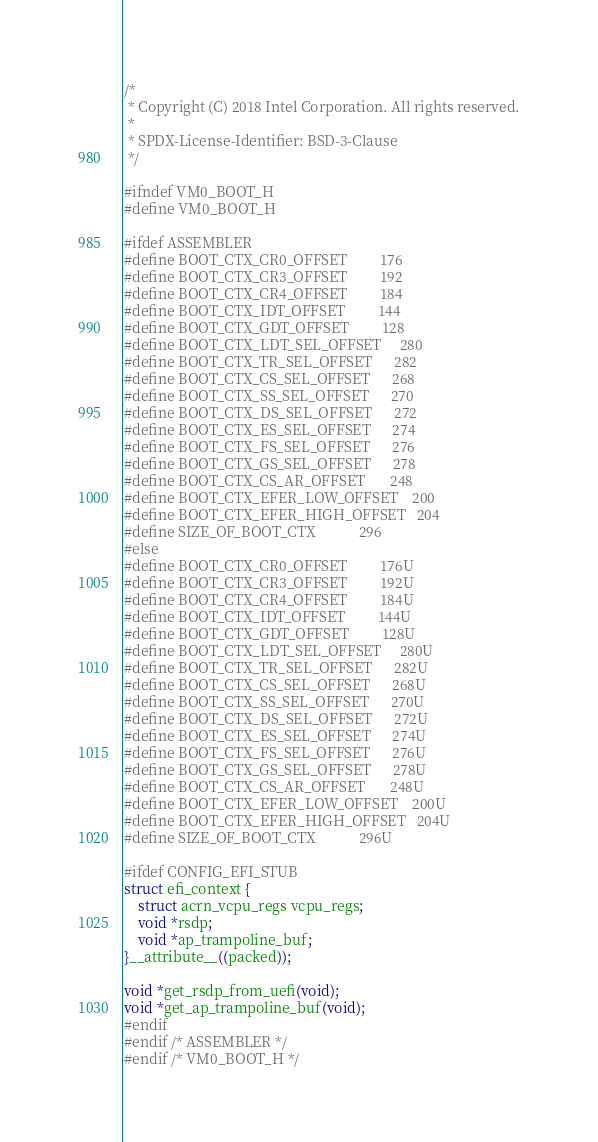Convert code to text. <code><loc_0><loc_0><loc_500><loc_500><_C_>/*
 * Copyright (C) 2018 Intel Corporation. All rights reserved.
 *
 * SPDX-License-Identifier: BSD-3-Clause
 */

#ifndef VM0_BOOT_H
#define VM0_BOOT_H

#ifdef ASSEMBLER
#define BOOT_CTX_CR0_OFFSET         176
#define BOOT_CTX_CR3_OFFSET         192
#define BOOT_CTX_CR4_OFFSET         184
#define BOOT_CTX_IDT_OFFSET         144
#define BOOT_CTX_GDT_OFFSET         128
#define BOOT_CTX_LDT_SEL_OFFSET     280
#define BOOT_CTX_TR_SEL_OFFSET      282
#define BOOT_CTX_CS_SEL_OFFSET      268
#define BOOT_CTX_SS_SEL_OFFSET      270
#define BOOT_CTX_DS_SEL_OFFSET      272
#define BOOT_CTX_ES_SEL_OFFSET      274
#define BOOT_CTX_FS_SEL_OFFSET      276
#define BOOT_CTX_GS_SEL_OFFSET      278
#define BOOT_CTX_CS_AR_OFFSET       248
#define BOOT_CTX_EFER_LOW_OFFSET    200
#define BOOT_CTX_EFER_HIGH_OFFSET   204
#define SIZE_OF_BOOT_CTX            296
#else
#define BOOT_CTX_CR0_OFFSET         176U
#define BOOT_CTX_CR3_OFFSET         192U
#define BOOT_CTX_CR4_OFFSET         184U
#define BOOT_CTX_IDT_OFFSET         144U
#define BOOT_CTX_GDT_OFFSET         128U
#define BOOT_CTX_LDT_SEL_OFFSET     280U
#define BOOT_CTX_TR_SEL_OFFSET      282U
#define BOOT_CTX_CS_SEL_OFFSET      268U
#define BOOT_CTX_SS_SEL_OFFSET      270U
#define BOOT_CTX_DS_SEL_OFFSET      272U
#define BOOT_CTX_ES_SEL_OFFSET      274U
#define BOOT_CTX_FS_SEL_OFFSET      276U
#define BOOT_CTX_GS_SEL_OFFSET      278U
#define BOOT_CTX_CS_AR_OFFSET       248U
#define BOOT_CTX_EFER_LOW_OFFSET    200U
#define BOOT_CTX_EFER_HIGH_OFFSET   204U
#define SIZE_OF_BOOT_CTX            296U

#ifdef CONFIG_EFI_STUB
struct efi_context {
	struct acrn_vcpu_regs vcpu_regs;
	void *rsdp;
	void *ap_trampoline_buf;
}__attribute__((packed));

void *get_rsdp_from_uefi(void);
void *get_ap_trampoline_buf(void);
#endif
#endif /* ASSEMBLER */
#endif /* VM0_BOOT_H */
</code> 